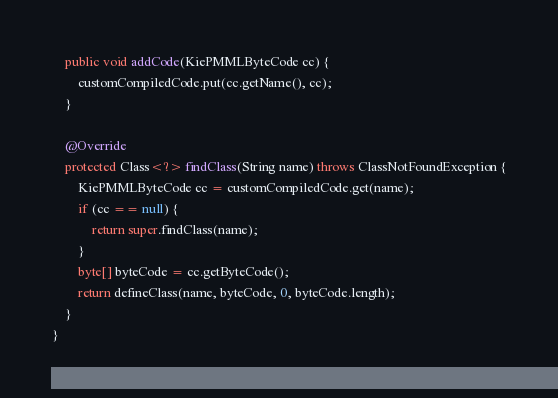Convert code to text. <code><loc_0><loc_0><loc_500><loc_500><_Java_>    public void addCode(KiePMMLByteCode cc) {
        customCompiledCode.put(cc.getName(), cc);
    }

    @Override
    protected Class<?> findClass(String name) throws ClassNotFoundException {
        KiePMMLByteCode cc = customCompiledCode.get(name);
        if (cc == null) {
            return super.findClass(name);
        }
        byte[] byteCode = cc.getByteCode();
        return defineClass(name, byteCode, 0, byteCode.length);
    }
}</code> 